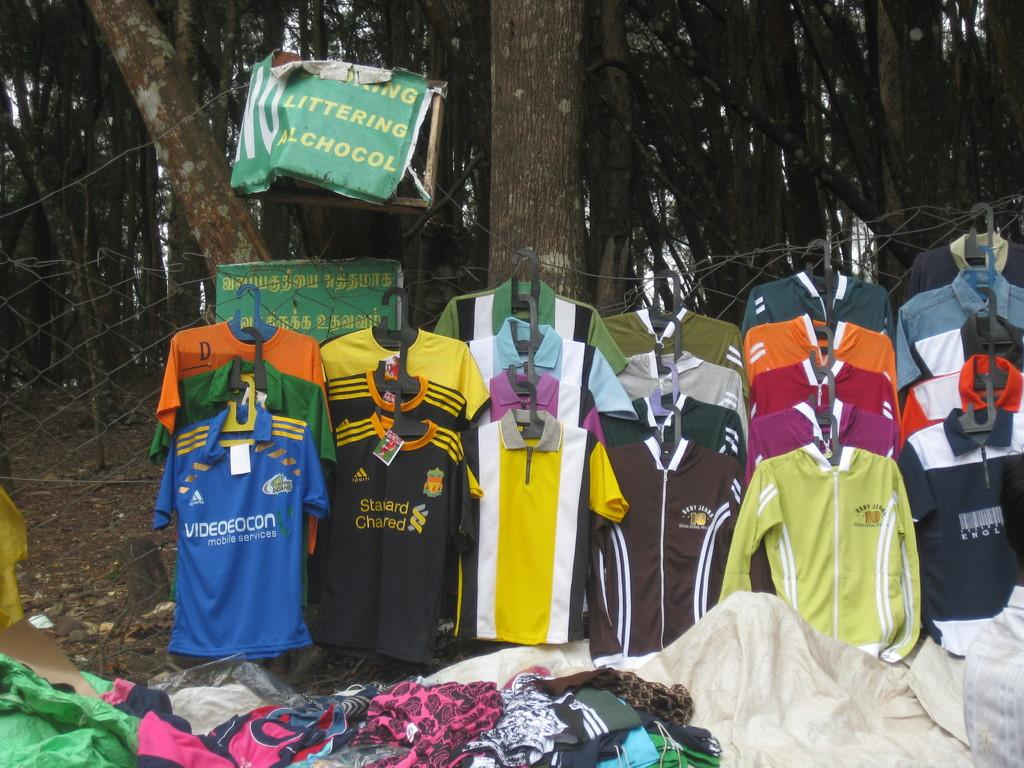Provide a one-sentence caption for the provided image. some clothing spread out in the woods with a sign above saying littering and alcohol prohibited. 